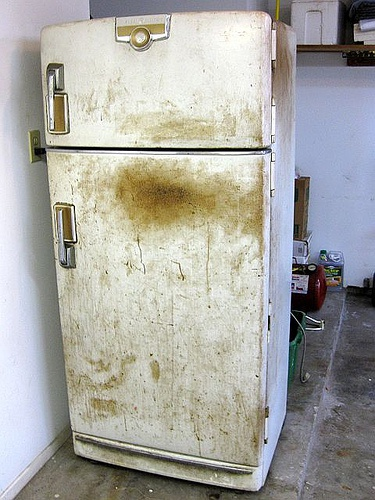Describe the objects in this image and their specific colors. I can see a refrigerator in lightgray, darkgray, and tan tones in this image. 